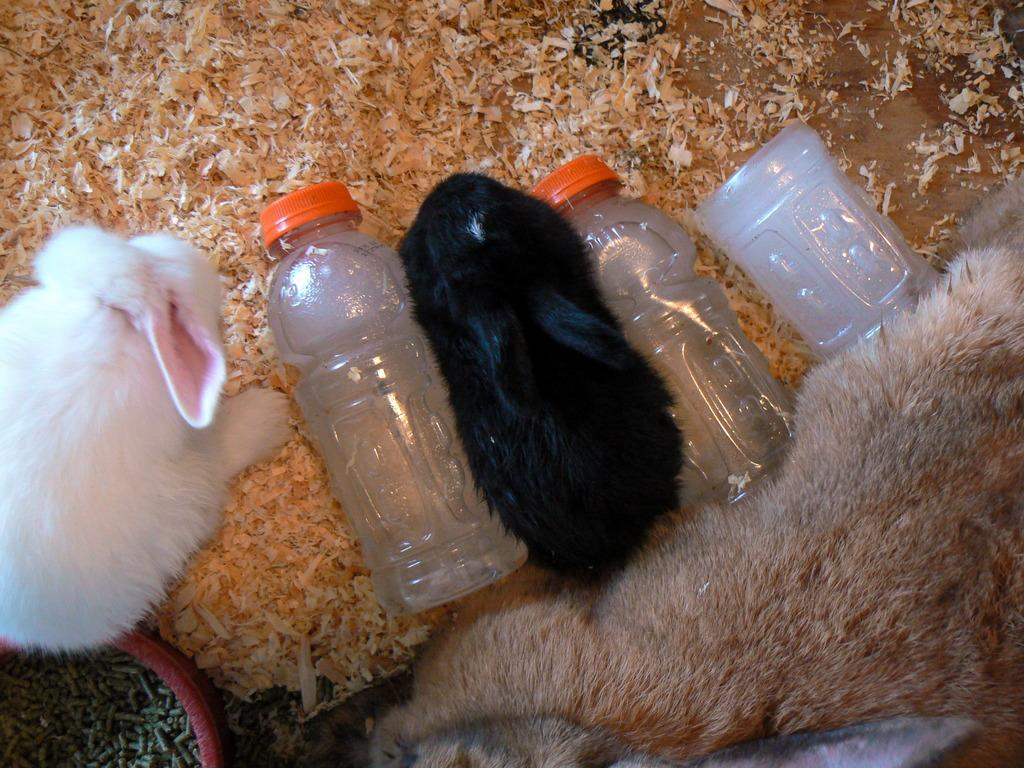How many rabbits are present in the image? There are two rabbits in the image. What else can be seen besides the rabbits? There are three bottles and a pot with grains in the image. Can you describe the pot in the image? The pot in the image contains grains. What is located at the bottom of the image? There is an animal at the bottom of the image. What type of disease is being treated by the rabbits in the image? There is no indication of any disease or treatment in the image; it simply features two rabbits, three bottles, a pot with grains, and an animal at the bottom. 